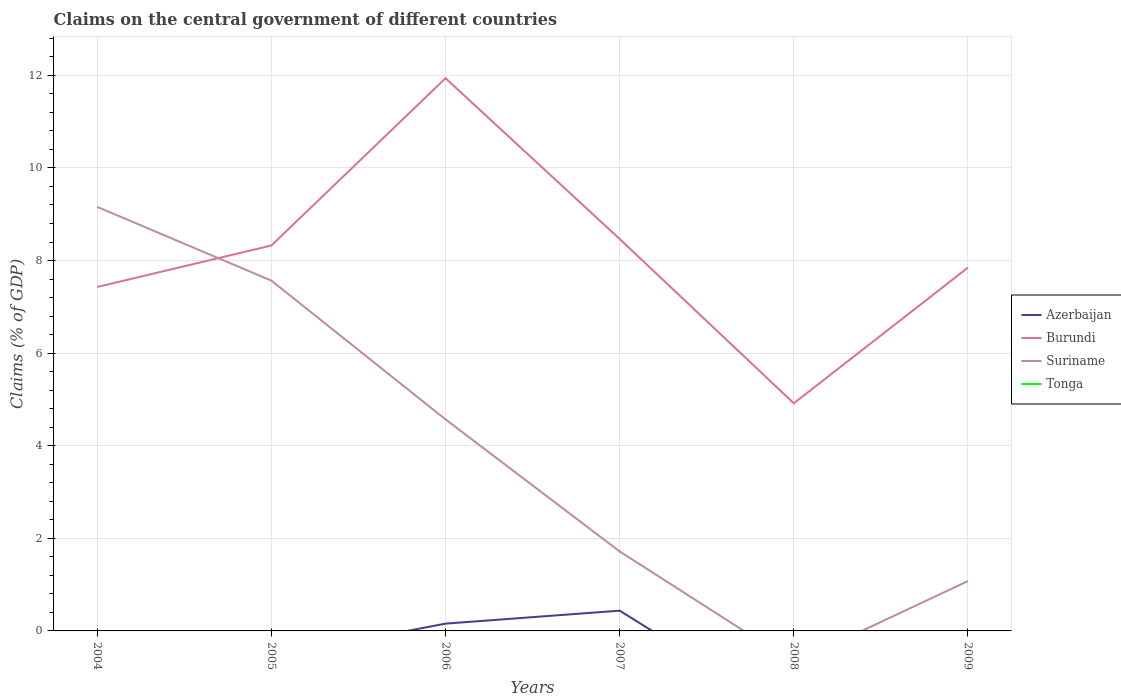How many different coloured lines are there?
Your response must be concise. 3. Across all years, what is the maximum percentage of GDP claimed on the central government in Suriname?
Keep it short and to the point. 0. What is the total percentage of GDP claimed on the central government in Burundi in the graph?
Keep it short and to the point. -0.9. What is the difference between the highest and the second highest percentage of GDP claimed on the central government in Suriname?
Offer a terse response. 9.16. Is the percentage of GDP claimed on the central government in Suriname strictly greater than the percentage of GDP claimed on the central government in Tonga over the years?
Your answer should be very brief. No. How many lines are there?
Your response must be concise. 3. Does the graph contain any zero values?
Your answer should be very brief. Yes. Does the graph contain grids?
Offer a terse response. Yes. Where does the legend appear in the graph?
Keep it short and to the point. Center right. How many legend labels are there?
Offer a terse response. 4. How are the legend labels stacked?
Keep it short and to the point. Vertical. What is the title of the graph?
Keep it short and to the point. Claims on the central government of different countries. Does "Middle East & North Africa (all income levels)" appear as one of the legend labels in the graph?
Ensure brevity in your answer.  No. What is the label or title of the Y-axis?
Provide a short and direct response. Claims (% of GDP). What is the Claims (% of GDP) of Burundi in 2004?
Make the answer very short. 7.43. What is the Claims (% of GDP) of Suriname in 2004?
Your response must be concise. 9.16. What is the Claims (% of GDP) in Tonga in 2004?
Provide a succinct answer. 0. What is the Claims (% of GDP) of Azerbaijan in 2005?
Provide a succinct answer. 0. What is the Claims (% of GDP) in Burundi in 2005?
Provide a succinct answer. 8.32. What is the Claims (% of GDP) in Suriname in 2005?
Ensure brevity in your answer.  7.57. What is the Claims (% of GDP) in Tonga in 2005?
Your response must be concise. 0. What is the Claims (% of GDP) of Azerbaijan in 2006?
Your answer should be compact. 0.16. What is the Claims (% of GDP) of Burundi in 2006?
Make the answer very short. 11.94. What is the Claims (% of GDP) of Suriname in 2006?
Provide a short and direct response. 4.57. What is the Claims (% of GDP) in Azerbaijan in 2007?
Ensure brevity in your answer.  0.44. What is the Claims (% of GDP) of Burundi in 2007?
Ensure brevity in your answer.  8.47. What is the Claims (% of GDP) of Suriname in 2007?
Provide a succinct answer. 1.72. What is the Claims (% of GDP) in Tonga in 2007?
Offer a terse response. 0. What is the Claims (% of GDP) in Azerbaijan in 2008?
Offer a terse response. 0. What is the Claims (% of GDP) of Burundi in 2008?
Make the answer very short. 4.92. What is the Claims (% of GDP) of Burundi in 2009?
Offer a very short reply. 7.85. What is the Claims (% of GDP) of Suriname in 2009?
Offer a very short reply. 1.08. Across all years, what is the maximum Claims (% of GDP) in Azerbaijan?
Your answer should be compact. 0.44. Across all years, what is the maximum Claims (% of GDP) in Burundi?
Make the answer very short. 11.94. Across all years, what is the maximum Claims (% of GDP) in Suriname?
Provide a short and direct response. 9.16. Across all years, what is the minimum Claims (% of GDP) in Burundi?
Ensure brevity in your answer.  4.92. What is the total Claims (% of GDP) of Azerbaijan in the graph?
Provide a succinct answer. 0.6. What is the total Claims (% of GDP) of Burundi in the graph?
Keep it short and to the point. 48.92. What is the total Claims (% of GDP) of Suriname in the graph?
Your response must be concise. 24.09. What is the total Claims (% of GDP) of Tonga in the graph?
Your answer should be compact. 0. What is the difference between the Claims (% of GDP) of Burundi in 2004 and that in 2005?
Your response must be concise. -0.9. What is the difference between the Claims (% of GDP) in Suriname in 2004 and that in 2005?
Your answer should be compact. 1.59. What is the difference between the Claims (% of GDP) in Burundi in 2004 and that in 2006?
Your answer should be very brief. -4.51. What is the difference between the Claims (% of GDP) of Suriname in 2004 and that in 2006?
Offer a terse response. 4.59. What is the difference between the Claims (% of GDP) of Burundi in 2004 and that in 2007?
Provide a succinct answer. -1.04. What is the difference between the Claims (% of GDP) of Suriname in 2004 and that in 2007?
Your response must be concise. 7.44. What is the difference between the Claims (% of GDP) of Burundi in 2004 and that in 2008?
Ensure brevity in your answer.  2.51. What is the difference between the Claims (% of GDP) in Burundi in 2004 and that in 2009?
Make the answer very short. -0.42. What is the difference between the Claims (% of GDP) of Suriname in 2004 and that in 2009?
Provide a short and direct response. 8.08. What is the difference between the Claims (% of GDP) in Burundi in 2005 and that in 2006?
Provide a short and direct response. -3.61. What is the difference between the Claims (% of GDP) in Suriname in 2005 and that in 2006?
Your answer should be very brief. 3. What is the difference between the Claims (% of GDP) in Burundi in 2005 and that in 2007?
Offer a very short reply. -0.14. What is the difference between the Claims (% of GDP) in Suriname in 2005 and that in 2007?
Offer a very short reply. 5.85. What is the difference between the Claims (% of GDP) in Burundi in 2005 and that in 2008?
Offer a very short reply. 3.41. What is the difference between the Claims (% of GDP) in Burundi in 2005 and that in 2009?
Offer a terse response. 0.48. What is the difference between the Claims (% of GDP) in Suriname in 2005 and that in 2009?
Provide a succinct answer. 6.49. What is the difference between the Claims (% of GDP) of Azerbaijan in 2006 and that in 2007?
Offer a very short reply. -0.28. What is the difference between the Claims (% of GDP) of Burundi in 2006 and that in 2007?
Provide a succinct answer. 3.47. What is the difference between the Claims (% of GDP) of Suriname in 2006 and that in 2007?
Give a very brief answer. 2.85. What is the difference between the Claims (% of GDP) of Burundi in 2006 and that in 2008?
Your answer should be compact. 7.02. What is the difference between the Claims (% of GDP) in Burundi in 2006 and that in 2009?
Keep it short and to the point. 4.09. What is the difference between the Claims (% of GDP) in Suriname in 2006 and that in 2009?
Give a very brief answer. 3.49. What is the difference between the Claims (% of GDP) in Burundi in 2007 and that in 2008?
Keep it short and to the point. 3.55. What is the difference between the Claims (% of GDP) in Burundi in 2007 and that in 2009?
Keep it short and to the point. 0.62. What is the difference between the Claims (% of GDP) in Suriname in 2007 and that in 2009?
Keep it short and to the point. 0.64. What is the difference between the Claims (% of GDP) in Burundi in 2008 and that in 2009?
Provide a short and direct response. -2.93. What is the difference between the Claims (% of GDP) of Burundi in 2004 and the Claims (% of GDP) of Suriname in 2005?
Make the answer very short. -0.14. What is the difference between the Claims (% of GDP) of Burundi in 2004 and the Claims (% of GDP) of Suriname in 2006?
Provide a succinct answer. 2.86. What is the difference between the Claims (% of GDP) of Burundi in 2004 and the Claims (% of GDP) of Suriname in 2007?
Offer a very short reply. 5.71. What is the difference between the Claims (% of GDP) in Burundi in 2004 and the Claims (% of GDP) in Suriname in 2009?
Make the answer very short. 6.35. What is the difference between the Claims (% of GDP) in Burundi in 2005 and the Claims (% of GDP) in Suriname in 2006?
Your answer should be compact. 3.76. What is the difference between the Claims (% of GDP) in Burundi in 2005 and the Claims (% of GDP) in Suriname in 2007?
Provide a succinct answer. 6.61. What is the difference between the Claims (% of GDP) of Burundi in 2005 and the Claims (% of GDP) of Suriname in 2009?
Make the answer very short. 7.25. What is the difference between the Claims (% of GDP) in Azerbaijan in 2006 and the Claims (% of GDP) in Burundi in 2007?
Offer a very short reply. -8.31. What is the difference between the Claims (% of GDP) in Azerbaijan in 2006 and the Claims (% of GDP) in Suriname in 2007?
Offer a terse response. -1.56. What is the difference between the Claims (% of GDP) of Burundi in 2006 and the Claims (% of GDP) of Suriname in 2007?
Provide a short and direct response. 10.22. What is the difference between the Claims (% of GDP) of Azerbaijan in 2006 and the Claims (% of GDP) of Burundi in 2008?
Make the answer very short. -4.76. What is the difference between the Claims (% of GDP) in Azerbaijan in 2006 and the Claims (% of GDP) in Burundi in 2009?
Make the answer very short. -7.69. What is the difference between the Claims (% of GDP) of Azerbaijan in 2006 and the Claims (% of GDP) of Suriname in 2009?
Your response must be concise. -0.92. What is the difference between the Claims (% of GDP) in Burundi in 2006 and the Claims (% of GDP) in Suriname in 2009?
Your response must be concise. 10.86. What is the difference between the Claims (% of GDP) of Azerbaijan in 2007 and the Claims (% of GDP) of Burundi in 2008?
Your answer should be very brief. -4.48. What is the difference between the Claims (% of GDP) of Azerbaijan in 2007 and the Claims (% of GDP) of Burundi in 2009?
Offer a terse response. -7.41. What is the difference between the Claims (% of GDP) of Azerbaijan in 2007 and the Claims (% of GDP) of Suriname in 2009?
Offer a terse response. -0.64. What is the difference between the Claims (% of GDP) in Burundi in 2007 and the Claims (% of GDP) in Suriname in 2009?
Provide a succinct answer. 7.39. What is the difference between the Claims (% of GDP) of Burundi in 2008 and the Claims (% of GDP) of Suriname in 2009?
Offer a very short reply. 3.84. What is the average Claims (% of GDP) of Azerbaijan per year?
Give a very brief answer. 0.1. What is the average Claims (% of GDP) of Burundi per year?
Make the answer very short. 8.15. What is the average Claims (% of GDP) of Suriname per year?
Give a very brief answer. 4.01. What is the average Claims (% of GDP) in Tonga per year?
Provide a short and direct response. 0. In the year 2004, what is the difference between the Claims (% of GDP) in Burundi and Claims (% of GDP) in Suriname?
Your response must be concise. -1.73. In the year 2005, what is the difference between the Claims (% of GDP) in Burundi and Claims (% of GDP) in Suriname?
Keep it short and to the point. 0.76. In the year 2006, what is the difference between the Claims (% of GDP) in Azerbaijan and Claims (% of GDP) in Burundi?
Make the answer very short. -11.78. In the year 2006, what is the difference between the Claims (% of GDP) in Azerbaijan and Claims (% of GDP) in Suriname?
Keep it short and to the point. -4.41. In the year 2006, what is the difference between the Claims (% of GDP) in Burundi and Claims (% of GDP) in Suriname?
Provide a short and direct response. 7.37. In the year 2007, what is the difference between the Claims (% of GDP) of Azerbaijan and Claims (% of GDP) of Burundi?
Provide a short and direct response. -8.03. In the year 2007, what is the difference between the Claims (% of GDP) of Azerbaijan and Claims (% of GDP) of Suriname?
Provide a succinct answer. -1.28. In the year 2007, what is the difference between the Claims (% of GDP) of Burundi and Claims (% of GDP) of Suriname?
Make the answer very short. 6.75. In the year 2009, what is the difference between the Claims (% of GDP) in Burundi and Claims (% of GDP) in Suriname?
Your answer should be compact. 6.77. What is the ratio of the Claims (% of GDP) in Burundi in 2004 to that in 2005?
Offer a terse response. 0.89. What is the ratio of the Claims (% of GDP) in Suriname in 2004 to that in 2005?
Your response must be concise. 1.21. What is the ratio of the Claims (% of GDP) in Burundi in 2004 to that in 2006?
Ensure brevity in your answer.  0.62. What is the ratio of the Claims (% of GDP) of Suriname in 2004 to that in 2006?
Keep it short and to the point. 2. What is the ratio of the Claims (% of GDP) in Burundi in 2004 to that in 2007?
Your response must be concise. 0.88. What is the ratio of the Claims (% of GDP) in Suriname in 2004 to that in 2007?
Make the answer very short. 5.33. What is the ratio of the Claims (% of GDP) of Burundi in 2004 to that in 2008?
Your answer should be compact. 1.51. What is the ratio of the Claims (% of GDP) of Burundi in 2004 to that in 2009?
Offer a very short reply. 0.95. What is the ratio of the Claims (% of GDP) in Suriname in 2004 to that in 2009?
Offer a terse response. 8.51. What is the ratio of the Claims (% of GDP) of Burundi in 2005 to that in 2006?
Offer a very short reply. 0.7. What is the ratio of the Claims (% of GDP) in Suriname in 2005 to that in 2006?
Ensure brevity in your answer.  1.66. What is the ratio of the Claims (% of GDP) in Burundi in 2005 to that in 2007?
Make the answer very short. 0.98. What is the ratio of the Claims (% of GDP) in Suriname in 2005 to that in 2007?
Give a very brief answer. 4.41. What is the ratio of the Claims (% of GDP) of Burundi in 2005 to that in 2008?
Make the answer very short. 1.69. What is the ratio of the Claims (% of GDP) in Burundi in 2005 to that in 2009?
Keep it short and to the point. 1.06. What is the ratio of the Claims (% of GDP) of Suriname in 2005 to that in 2009?
Give a very brief answer. 7.03. What is the ratio of the Claims (% of GDP) of Azerbaijan in 2006 to that in 2007?
Make the answer very short. 0.36. What is the ratio of the Claims (% of GDP) in Burundi in 2006 to that in 2007?
Your answer should be compact. 1.41. What is the ratio of the Claims (% of GDP) in Suriname in 2006 to that in 2007?
Your response must be concise. 2.66. What is the ratio of the Claims (% of GDP) of Burundi in 2006 to that in 2008?
Ensure brevity in your answer.  2.43. What is the ratio of the Claims (% of GDP) of Burundi in 2006 to that in 2009?
Ensure brevity in your answer.  1.52. What is the ratio of the Claims (% of GDP) in Suriname in 2006 to that in 2009?
Offer a very short reply. 4.24. What is the ratio of the Claims (% of GDP) in Burundi in 2007 to that in 2008?
Ensure brevity in your answer.  1.72. What is the ratio of the Claims (% of GDP) in Burundi in 2007 to that in 2009?
Provide a short and direct response. 1.08. What is the ratio of the Claims (% of GDP) in Suriname in 2007 to that in 2009?
Your answer should be compact. 1.59. What is the ratio of the Claims (% of GDP) in Burundi in 2008 to that in 2009?
Offer a terse response. 0.63. What is the difference between the highest and the second highest Claims (% of GDP) of Burundi?
Offer a very short reply. 3.47. What is the difference between the highest and the second highest Claims (% of GDP) in Suriname?
Provide a succinct answer. 1.59. What is the difference between the highest and the lowest Claims (% of GDP) of Azerbaijan?
Offer a terse response. 0.44. What is the difference between the highest and the lowest Claims (% of GDP) of Burundi?
Your response must be concise. 7.02. What is the difference between the highest and the lowest Claims (% of GDP) in Suriname?
Provide a succinct answer. 9.16. 